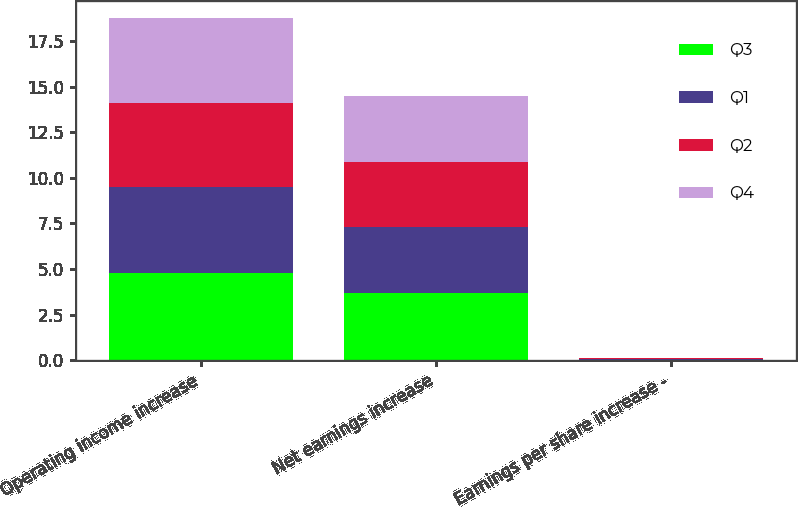Convert chart to OTSL. <chart><loc_0><loc_0><loc_500><loc_500><stacked_bar_chart><ecel><fcel>Operating income increase<fcel>Net earnings increase<fcel>Earnings per share increase -<nl><fcel>Q3<fcel>4.8<fcel>3.7<fcel>0.03<nl><fcel>Q1<fcel>4.7<fcel>3.6<fcel>0.03<nl><fcel>Q2<fcel>4.6<fcel>3.6<fcel>0.03<nl><fcel>Q4<fcel>4.7<fcel>3.6<fcel>0.03<nl></chart> 